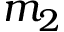Convert formula to latex. <formula><loc_0><loc_0><loc_500><loc_500>m _ { 2 }</formula> 